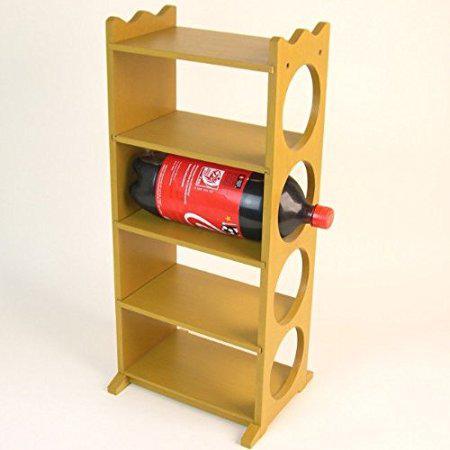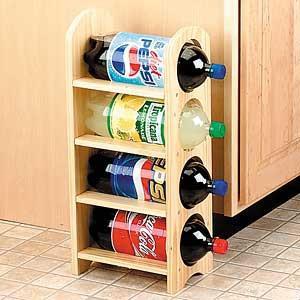The first image is the image on the left, the second image is the image on the right. Evaluate the accuracy of this statement regarding the images: "There are exactly five bottles of soda.". Is it true? Answer yes or no. Yes. The first image is the image on the left, the second image is the image on the right. Considering the images on both sides, is "In one of the images, a single red cola bottle sits on the second highest shelf of a shelf stack with 4 shelves on it." valid? Answer yes or no. Yes. 